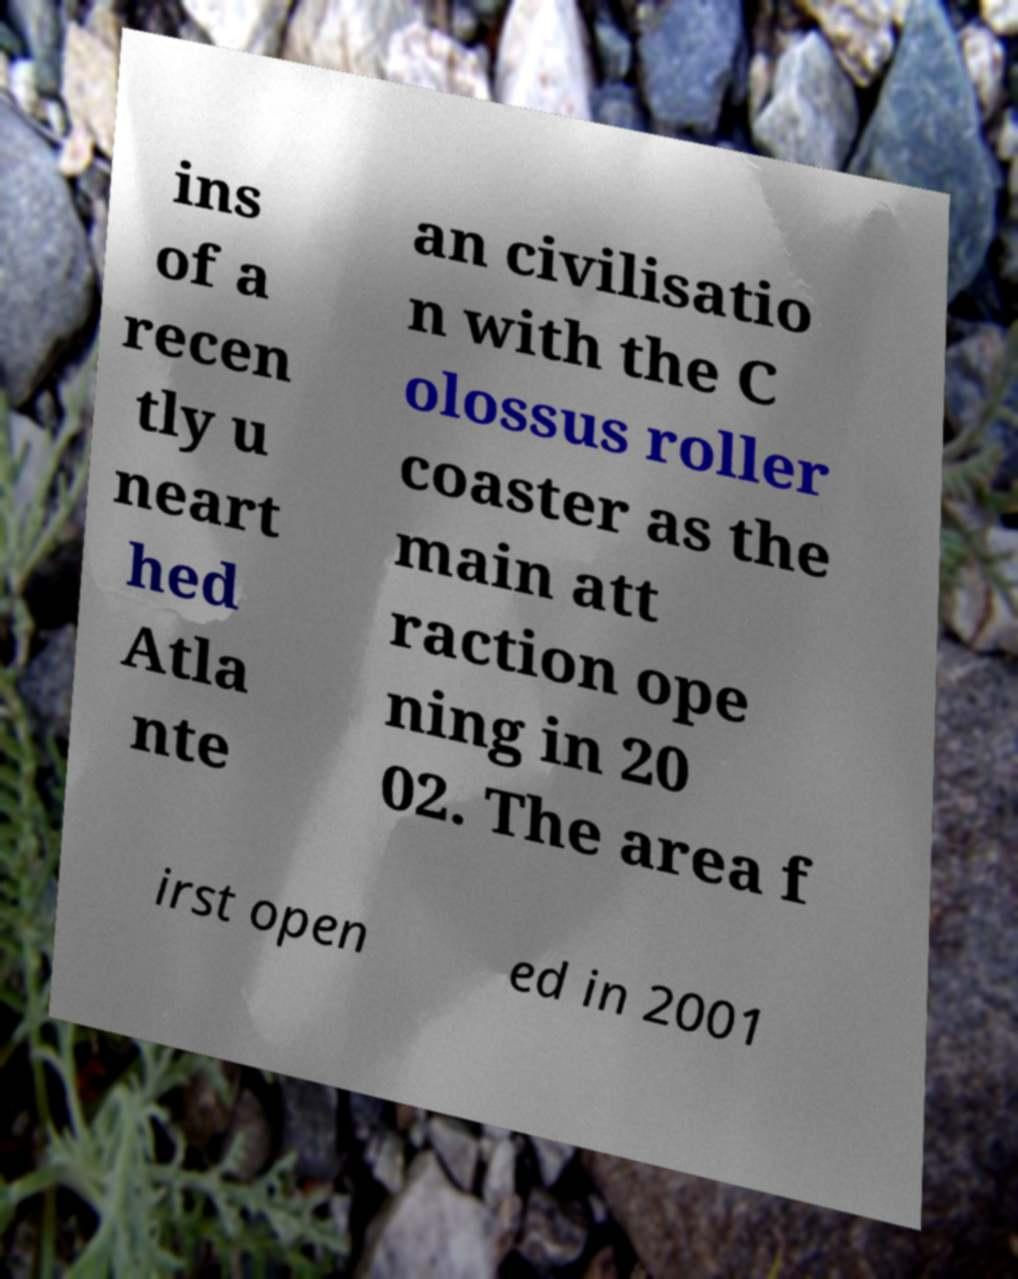What messages or text are displayed in this image? I need them in a readable, typed format. ins of a recen tly u neart hed Atla nte an civilisatio n with the C olossus roller coaster as the main att raction ope ning in 20 02. The area f irst open ed in 2001 